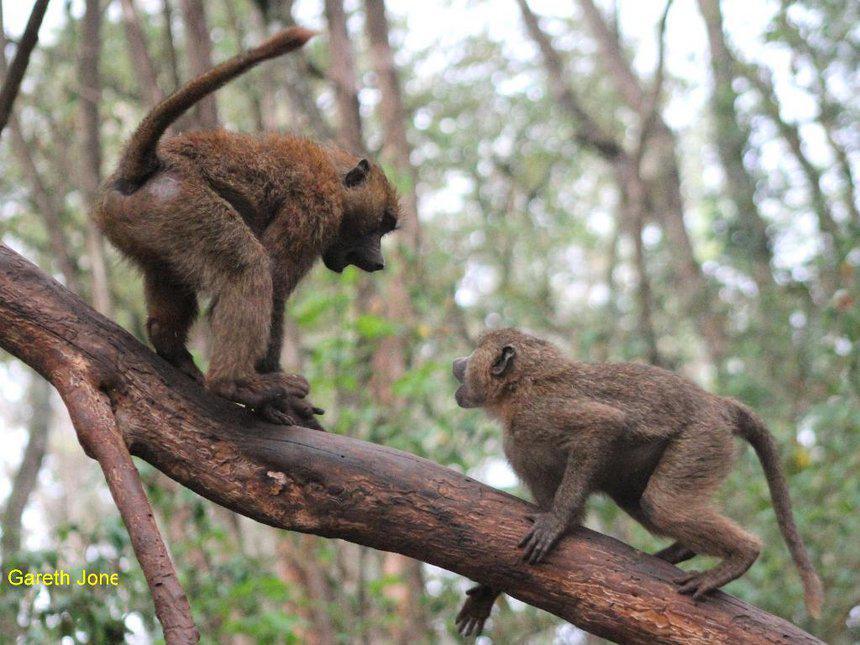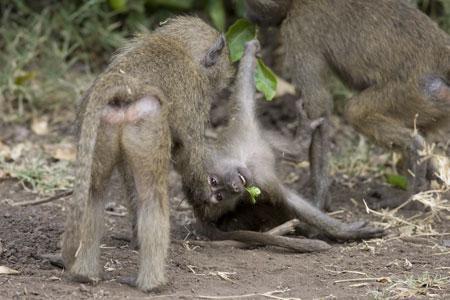The first image is the image on the left, the second image is the image on the right. Considering the images on both sides, is "There are no more than four monkeys." valid? Answer yes or no. No. The first image is the image on the left, the second image is the image on the right. Examine the images to the left and right. Is the description "In one of the images monkeys are in a tree." accurate? Answer yes or no. Yes. 